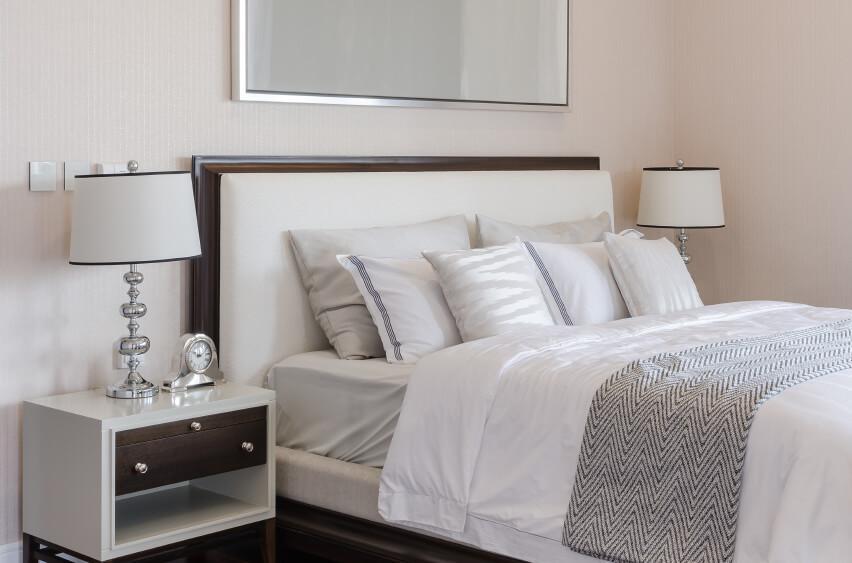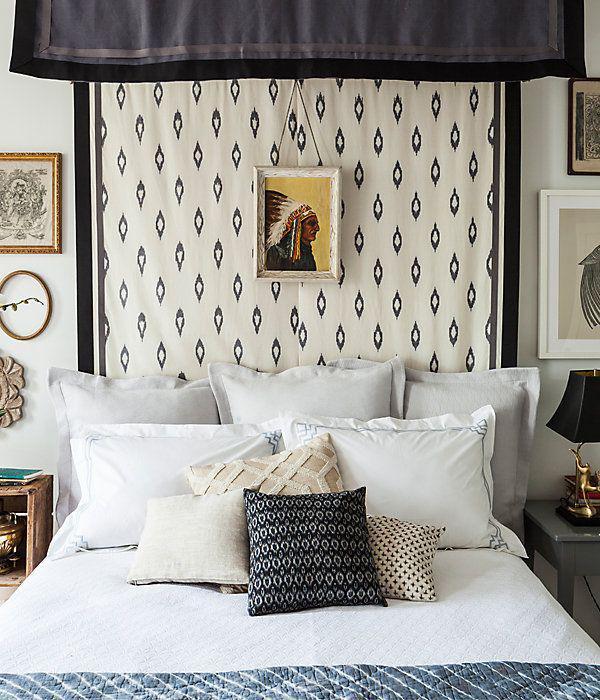The first image is the image on the left, the second image is the image on the right. Analyze the images presented: Is the assertion "In at least one image there is a bed with a light colored comforter and an arched triangle like bed board." valid? Answer yes or no. No. The first image is the image on the left, the second image is the image on the right. For the images displayed, is the sentence "The right image shows a narrow pillow centered in front of side-by-side pillows on a bed with an upholstered arch-topped headboard." factually correct? Answer yes or no. No. 